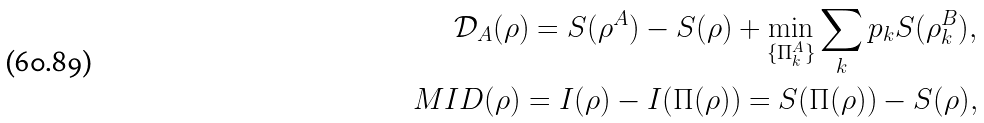Convert formula to latex. <formula><loc_0><loc_0><loc_500><loc_500>\mathcal { D } _ { A } ( \rho ) = S ( \rho ^ { A } ) - S ( \rho ) + \min _ { \{ \Pi ^ { A } _ { k } \} } \sum _ { k } p _ { k } S ( \rho ^ { B } _ { k } ) , \\ M I D ( \rho ) = I ( \rho ) - I ( \Pi ( \rho ) ) = S ( \Pi ( \rho ) ) - S ( \rho ) ,</formula> 